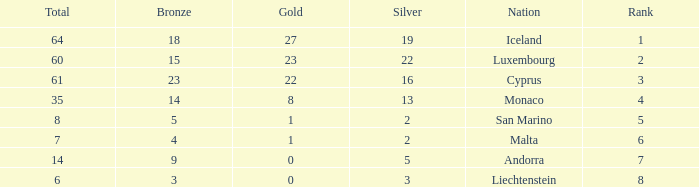How many bronzes for Iceland with over 2 silvers? 18.0. 